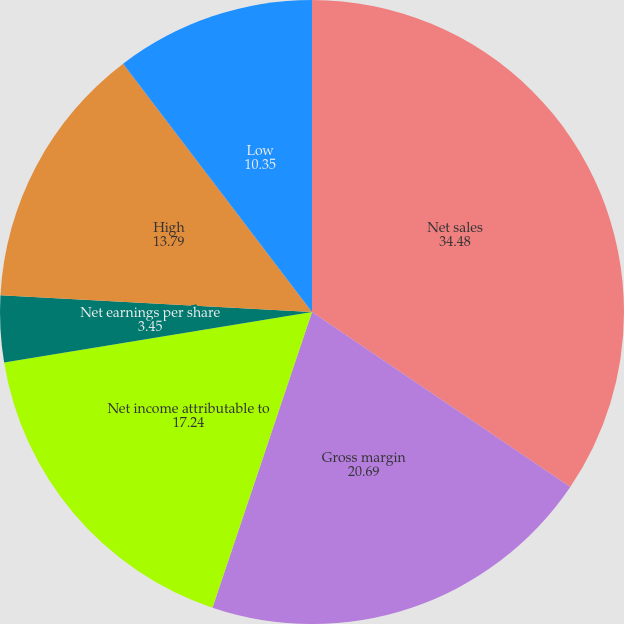<chart> <loc_0><loc_0><loc_500><loc_500><pie_chart><fcel>Net sales<fcel>Gross margin<fcel>Net income attributable to<fcel>Net earnings per share<fcel>Cash dividends per share<fcel>High<fcel>Low<nl><fcel>34.48%<fcel>20.69%<fcel>17.24%<fcel>3.45%<fcel>0.0%<fcel>13.79%<fcel>10.35%<nl></chart> 